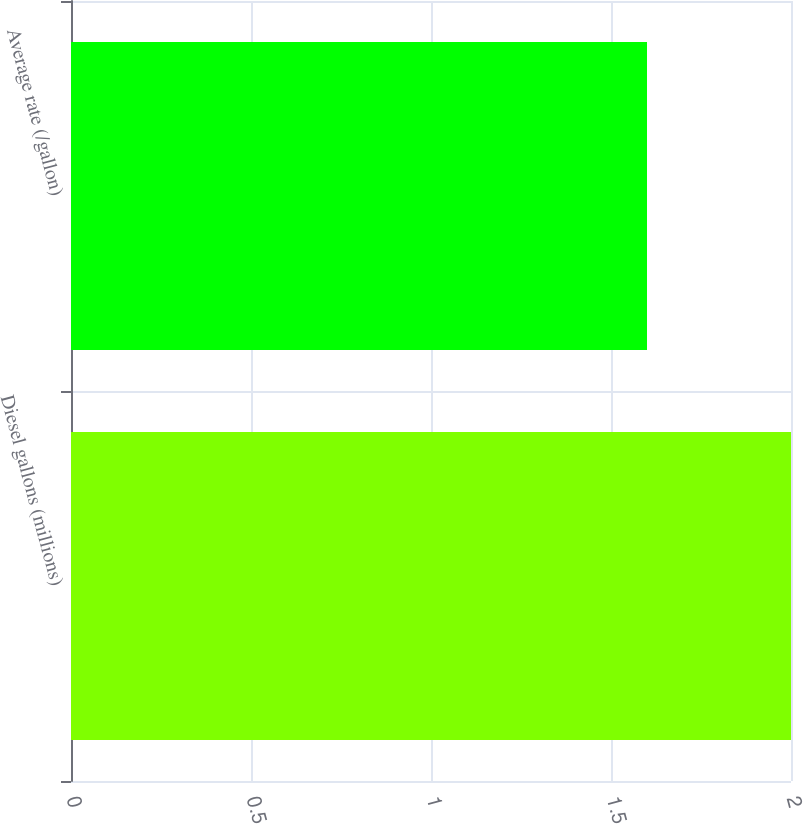Convert chart to OTSL. <chart><loc_0><loc_0><loc_500><loc_500><bar_chart><fcel>Diesel gallons (millions)<fcel>Average rate (/gallon)<nl><fcel>2<fcel>1.6<nl></chart> 